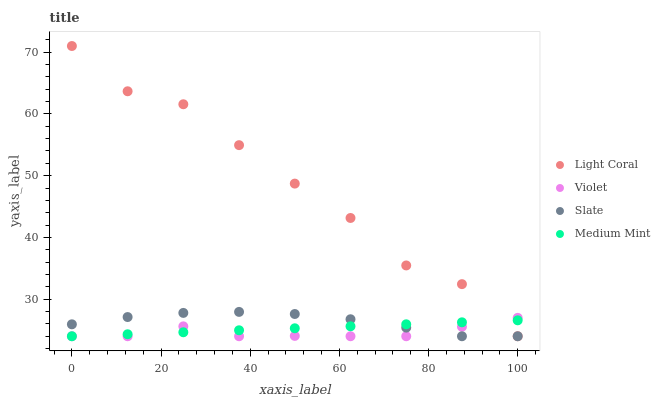Does Violet have the minimum area under the curve?
Answer yes or no. Yes. Does Light Coral have the maximum area under the curve?
Answer yes or no. Yes. Does Medium Mint have the minimum area under the curve?
Answer yes or no. No. Does Medium Mint have the maximum area under the curve?
Answer yes or no. No. Is Medium Mint the smoothest?
Answer yes or no. Yes. Is Light Coral the roughest?
Answer yes or no. Yes. Is Slate the smoothest?
Answer yes or no. No. Is Slate the roughest?
Answer yes or no. No. Does Light Coral have the lowest value?
Answer yes or no. Yes. Does Light Coral have the highest value?
Answer yes or no. Yes. Does Slate have the highest value?
Answer yes or no. No. Does Medium Mint intersect Light Coral?
Answer yes or no. Yes. Is Medium Mint less than Light Coral?
Answer yes or no. No. Is Medium Mint greater than Light Coral?
Answer yes or no. No. 